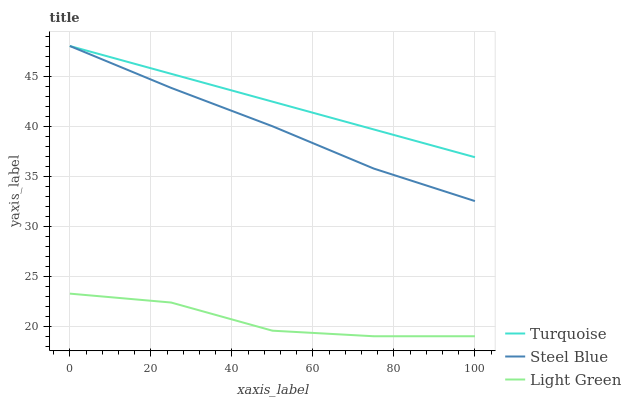Does Light Green have the minimum area under the curve?
Answer yes or no. Yes. Does Turquoise have the maximum area under the curve?
Answer yes or no. Yes. Does Steel Blue have the minimum area under the curve?
Answer yes or no. No. Does Steel Blue have the maximum area under the curve?
Answer yes or no. No. Is Turquoise the smoothest?
Answer yes or no. Yes. Is Light Green the roughest?
Answer yes or no. Yes. Is Steel Blue the smoothest?
Answer yes or no. No. Is Steel Blue the roughest?
Answer yes or no. No. Does Light Green have the lowest value?
Answer yes or no. Yes. Does Steel Blue have the lowest value?
Answer yes or no. No. Does Steel Blue have the highest value?
Answer yes or no. Yes. Does Light Green have the highest value?
Answer yes or no. No. Is Light Green less than Steel Blue?
Answer yes or no. Yes. Is Steel Blue greater than Light Green?
Answer yes or no. Yes. Does Turquoise intersect Steel Blue?
Answer yes or no. Yes. Is Turquoise less than Steel Blue?
Answer yes or no. No. Is Turquoise greater than Steel Blue?
Answer yes or no. No. Does Light Green intersect Steel Blue?
Answer yes or no. No. 